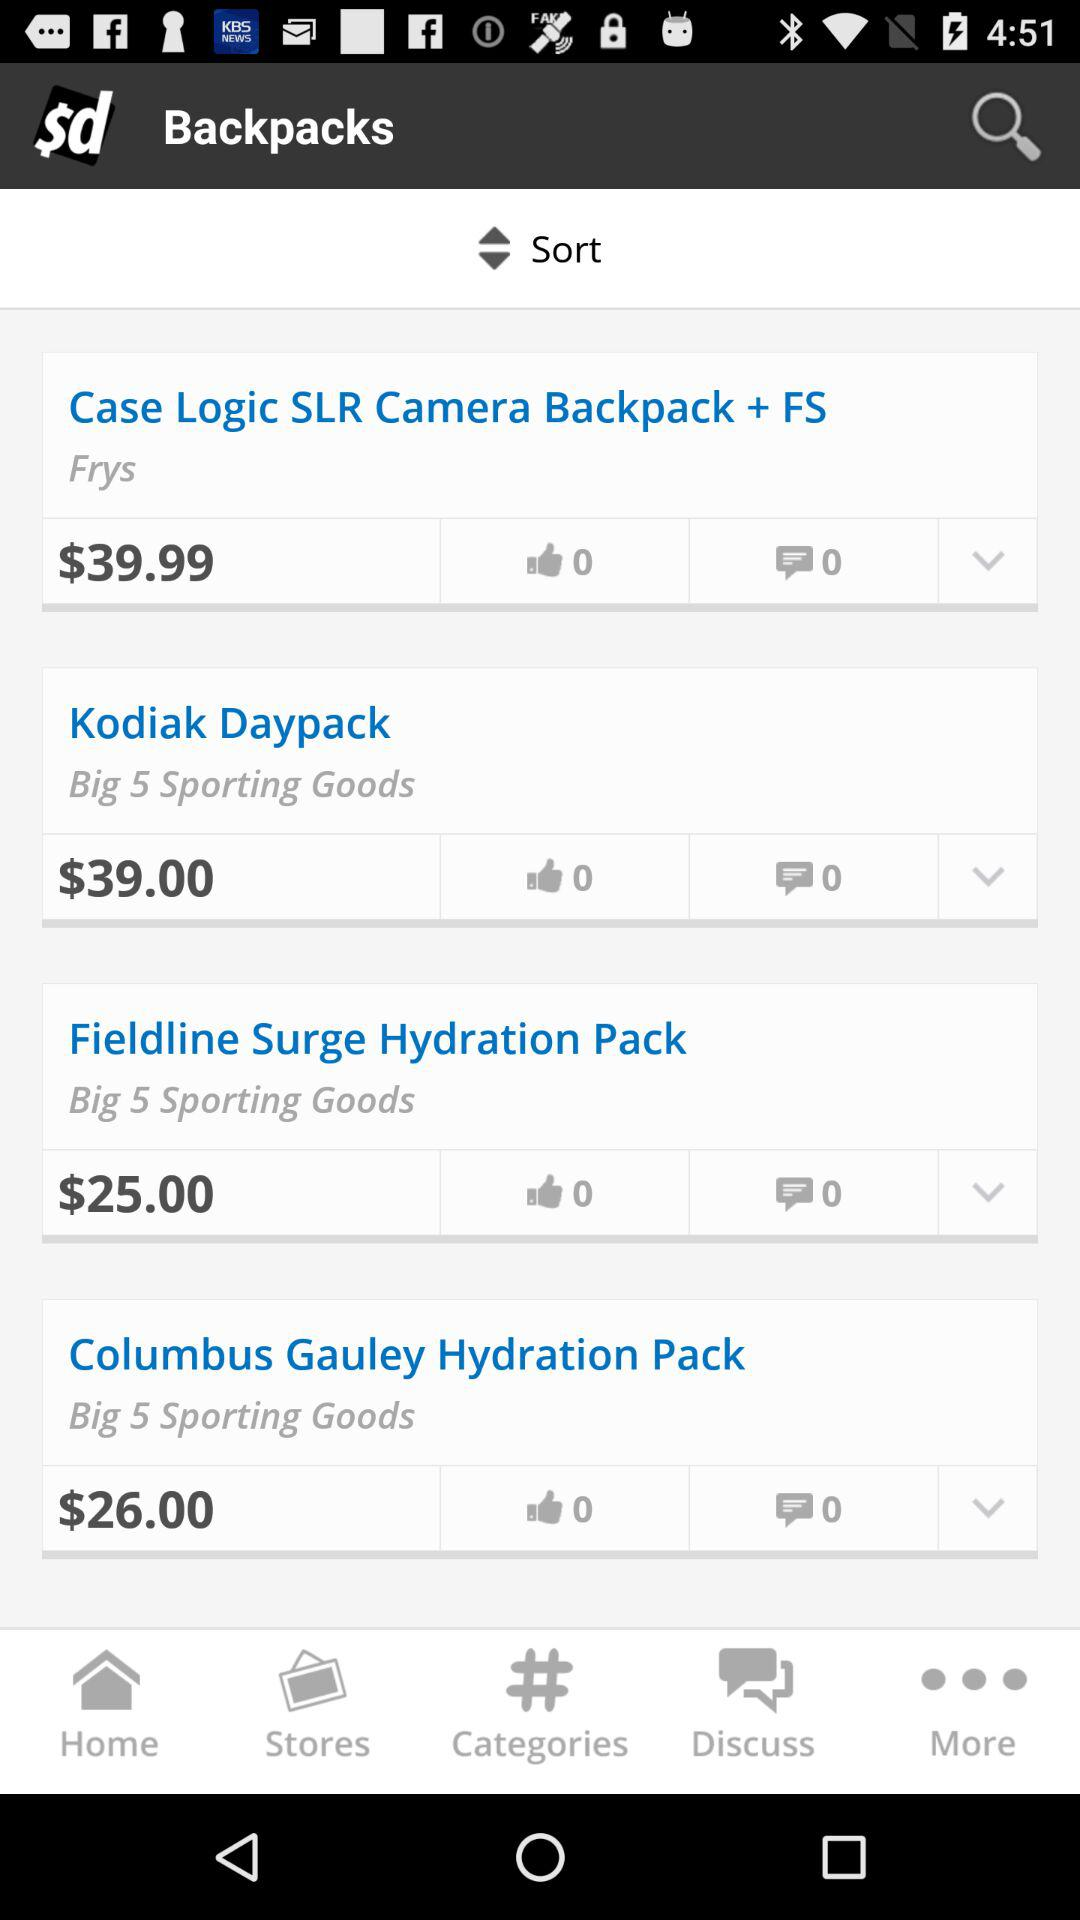What is the price of the "Kodiak Daypack"? The price is $39. 